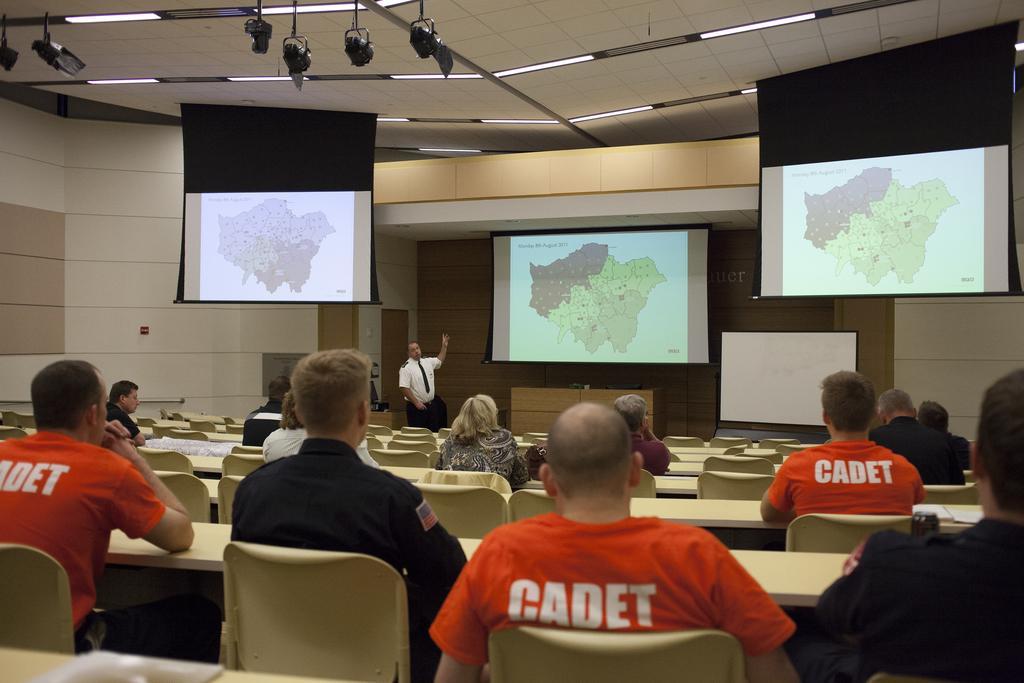Describe this image in one or two sentences. This is a closed auditorium in which there are some group of persons sitting on chairs and at the background of the image there is a person wearing white color dress standing and explaining about some thing which is displaying on projector screens, there is wall and at the top of the image there are some lights and projectors. 